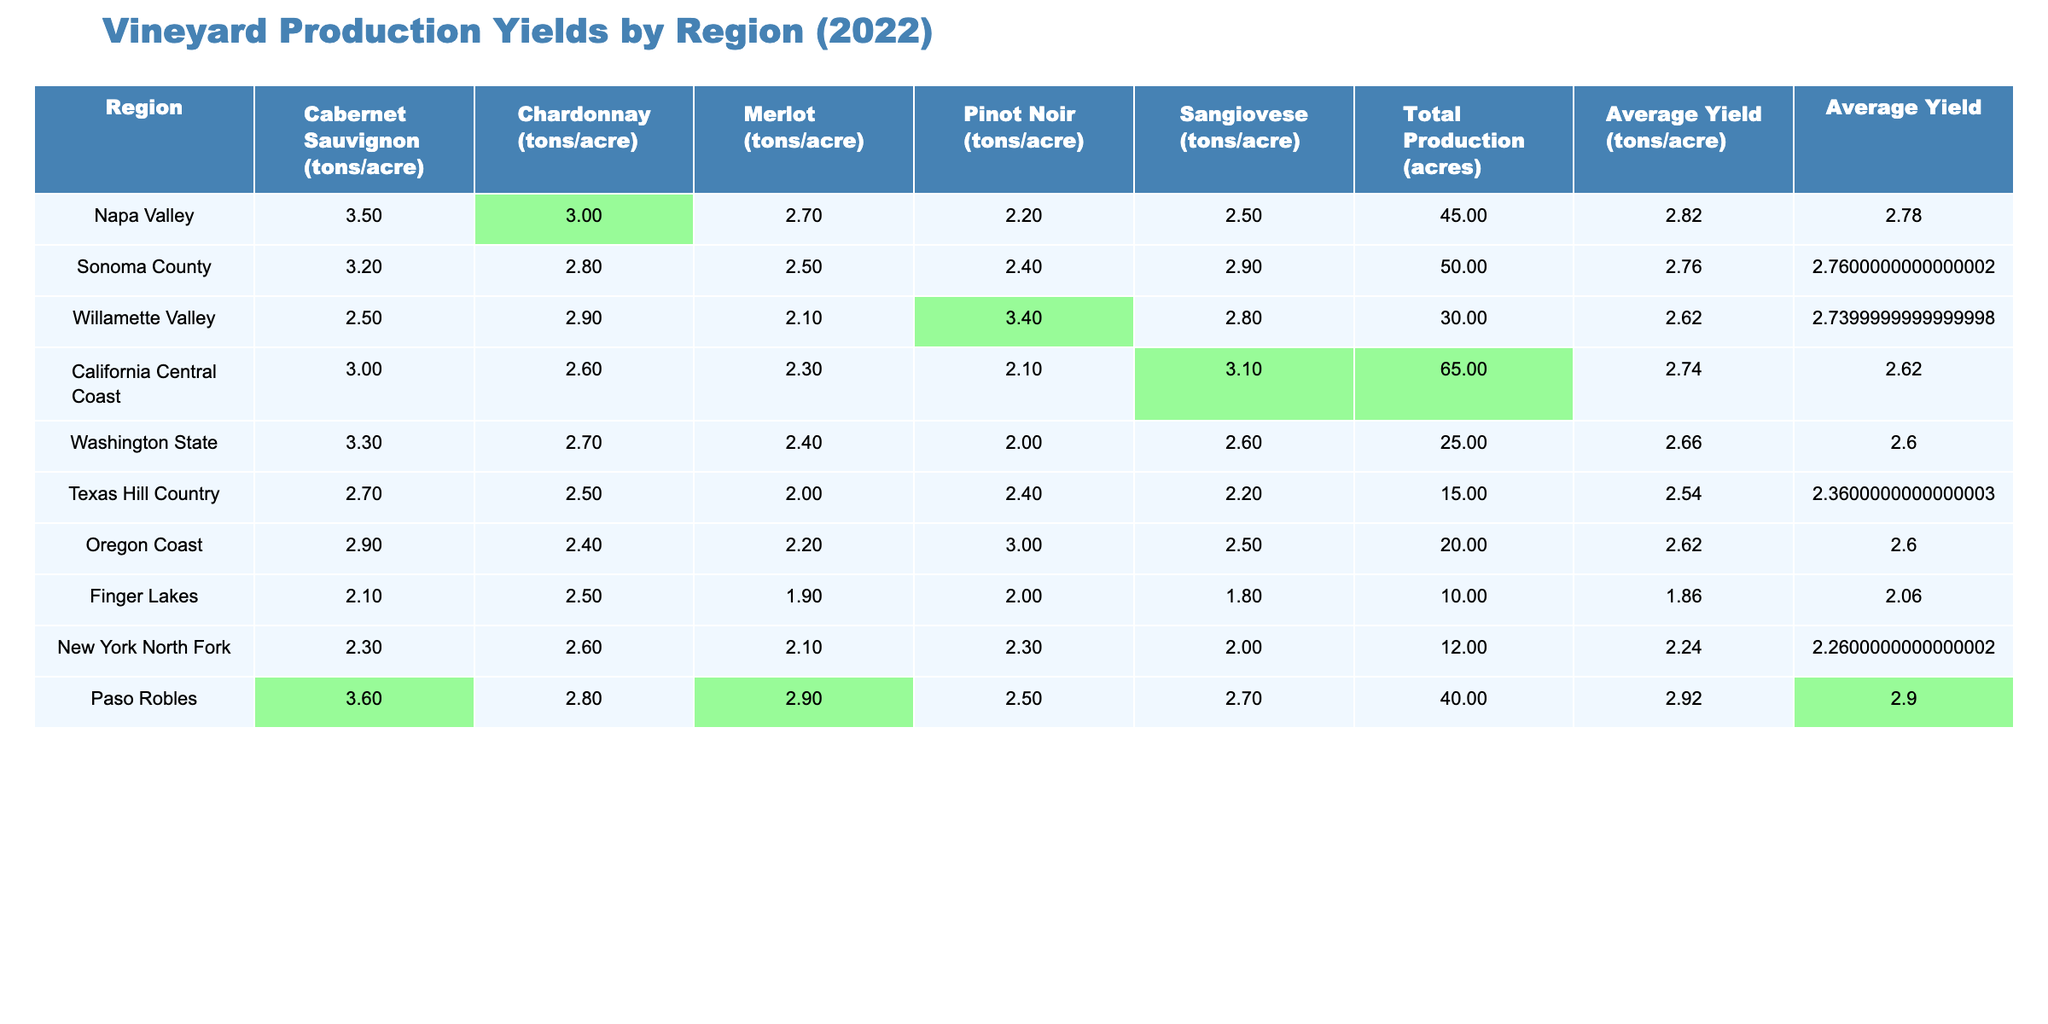What's the cabernet sauvignon yield in Napa Valley? The table shows that the cabernet sauvignon yield for Napa Valley is listed as 3.5 tons per acre.
Answer: 3.5 Which region has the highest average yield? The maximum average yield value is highlighted in the table. By examining the Average Yield column, we see that it is highest in Paso Robles, at 2.92 tons per acre.
Answer: Paso Robles Is the average yield for Sonoma County higher than that of Willamette Valley? By comparing the Average Yield values for both counties, Sonoma County has an average yield of 2.76 tons per acre while Willamette Valley has 2.62 tons per acre. Therefore, Sonoma County’s yield is higher.
Answer: Yes What is the total production area for Texas Hill Country? The Total Production value for Texas Hill Country is directly listed in the table as 15 acres.
Answer: 15 acres Calculate the difference in average yield between Napa Valley and Texas Hill Country. The average yield for Napa Valley is 2.82 tons per acre and for Texas Hill Country it is 2.54 tons per acre. The difference is calculated as 2.82 - 2.54 = 0.28 tons per acre.
Answer: 0.28 tons per acre Which region has the lowest Chardonnay yield? We look at the Chardonnay yields for each region, finding that Finger Lakes has the lowest value of 2.5 tons per acre.
Answer: Finger Lakes What is the total average yield across all regions listed? To find the total average yield, we sum the average yields from each region and divide by the number of regions (8). The total sum is (2.82 + 2.76 + 2.62 + 2.74 + 2.66 + 2.54 + 2.62 + 2.24) = 20.56 tons, and dividing by 8 gives us an average of 2.57 tons per acre.
Answer: 2.57 tons per acre Is it true that Napa Valley has the highest yield for at least one variety of grape? By checking the grape yield values, Napa Valley not only has the highest cabernet sauvignon yield (3.5 tons/acre) but also has competitive yields across various grape types.
Answer: Yes What is the average yield of Oregon Coast compared to Washington State? The average yield for Oregon Coast is 2.62 tons per acre, while Washington State’s average yield is 2.66 tons per acre. Hence, Oregon Coast has a lower average yield.
Answer: Oregon Coast has a lower average yield How many regions have an average yield above 2.7 tons per acre? By checking the Average Yield column, we see that Napa Valley (2.82), Paso Robles (2.92), and California Central Coast (2.74) exceed 2.7 tons per acre. This totals to three regions.
Answer: Three regions 